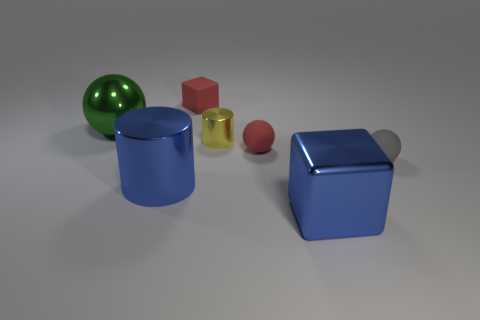What is the tiny gray object made of?
Offer a very short reply. Rubber. Is the big blue cylinder made of the same material as the small cube?
Your answer should be very brief. No. How many matte objects are either spheres or objects?
Offer a very short reply. 3. What shape is the small red object behind the small yellow cylinder?
Ensure brevity in your answer.  Cube. The yellow cylinder that is made of the same material as the large green object is what size?
Provide a succinct answer. Small. What shape is the thing that is both on the right side of the small red ball and on the left side of the gray matte ball?
Your response must be concise. Cube. There is a cube in front of the small gray matte object; does it have the same color as the large cylinder?
Offer a terse response. Yes. Is the shape of the big object to the left of the big blue shiny cylinder the same as the small red matte object in front of the green object?
Your answer should be compact. Yes. There is a blue object on the left side of the tiny red matte cube; what size is it?
Make the answer very short. Large. What is the size of the cube in front of the metallic thing behind the yellow shiny object?
Provide a succinct answer. Large. 